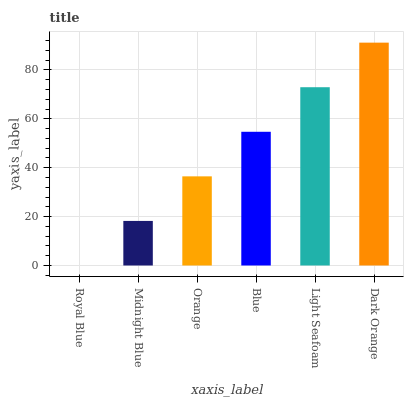Is Midnight Blue the minimum?
Answer yes or no. No. Is Midnight Blue the maximum?
Answer yes or no. No. Is Midnight Blue greater than Royal Blue?
Answer yes or no. Yes. Is Royal Blue less than Midnight Blue?
Answer yes or no. Yes. Is Royal Blue greater than Midnight Blue?
Answer yes or no. No. Is Midnight Blue less than Royal Blue?
Answer yes or no. No. Is Blue the high median?
Answer yes or no. Yes. Is Orange the low median?
Answer yes or no. Yes. Is Midnight Blue the high median?
Answer yes or no. No. Is Dark Orange the low median?
Answer yes or no. No. 